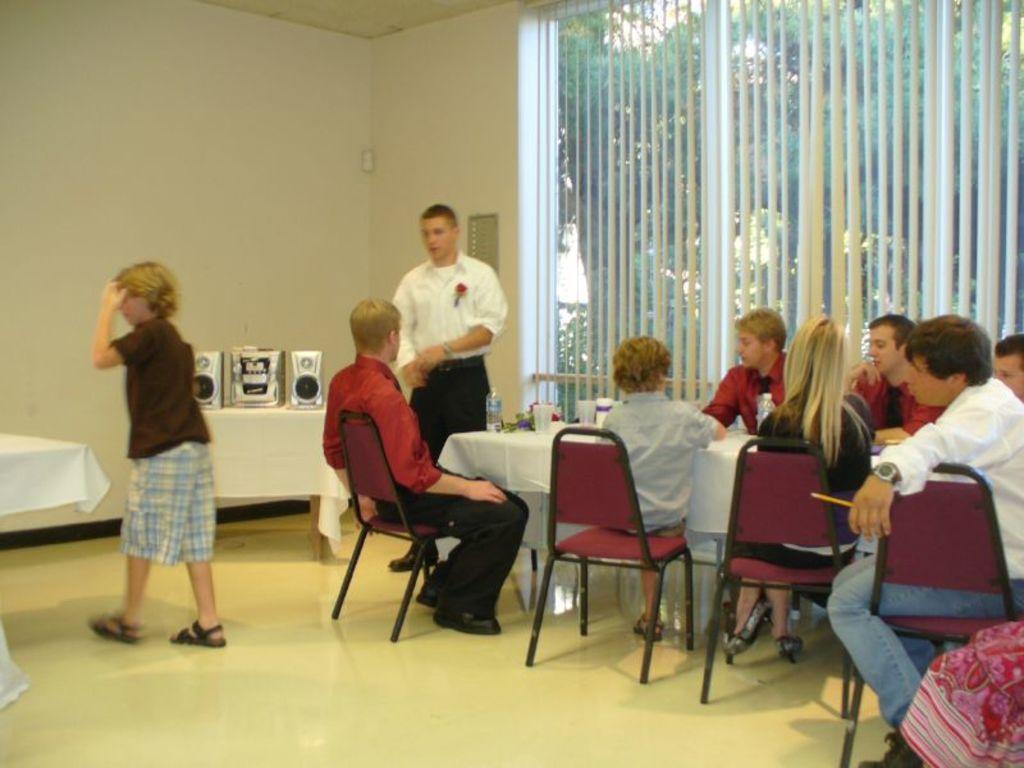How would you summarize this image in a sentence or two? In this image I can see the group of people. Among them some people are sitting in-front of the table and few people are standing. On the table there is a glass and bottle. To the left there is a sound box. In the back there is a window. 